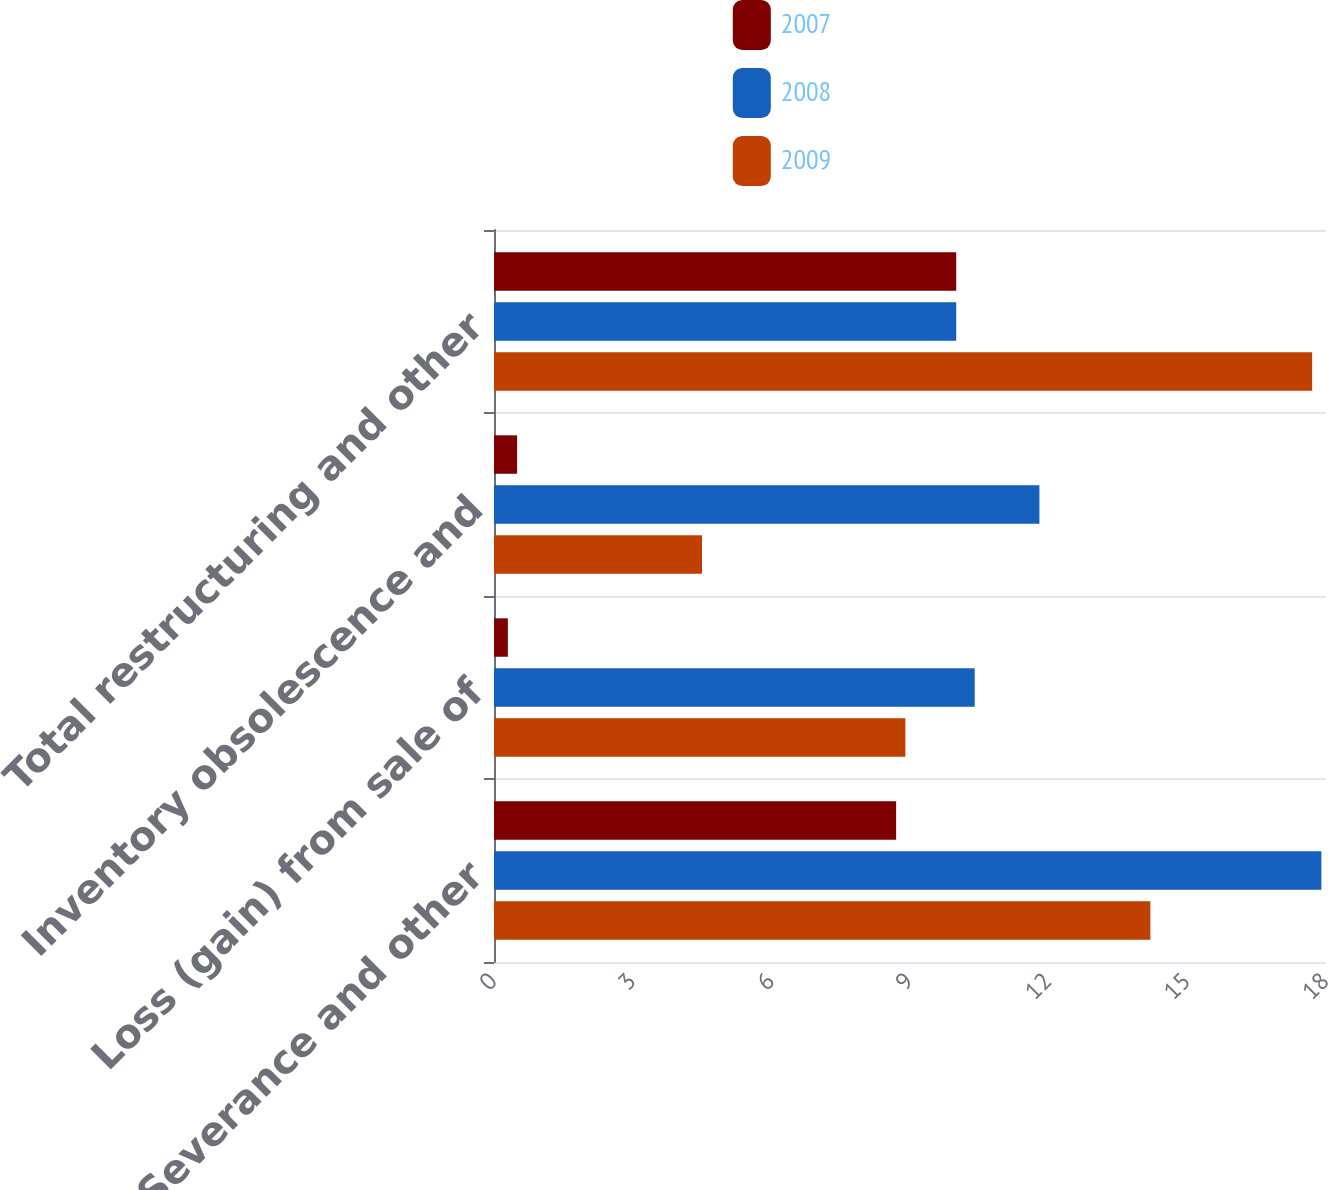<chart> <loc_0><loc_0><loc_500><loc_500><stacked_bar_chart><ecel><fcel>Severance and other<fcel>Loss (gain) from sale of<fcel>Inventory obsolescence and<fcel>Total restructuring and other<nl><fcel>2007<fcel>8.7<fcel>0.3<fcel>0.5<fcel>10<nl><fcel>2008<fcel>17.9<fcel>10.4<fcel>11.8<fcel>10<nl><fcel>2009<fcel>14.2<fcel>8.9<fcel>4.5<fcel>17.7<nl></chart> 